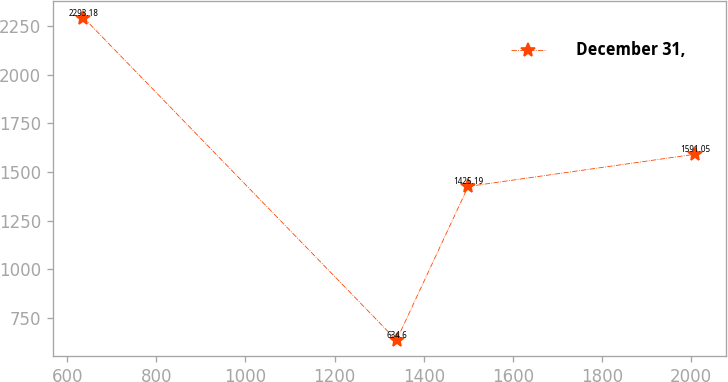<chart> <loc_0><loc_0><loc_500><loc_500><line_chart><ecel><fcel>December 31,<nl><fcel>636.63<fcel>2293.18<nl><fcel>1338.97<fcel>634.6<nl><fcel>1499.73<fcel>1425.19<nl><fcel>2009.41<fcel>1591.05<nl></chart> 